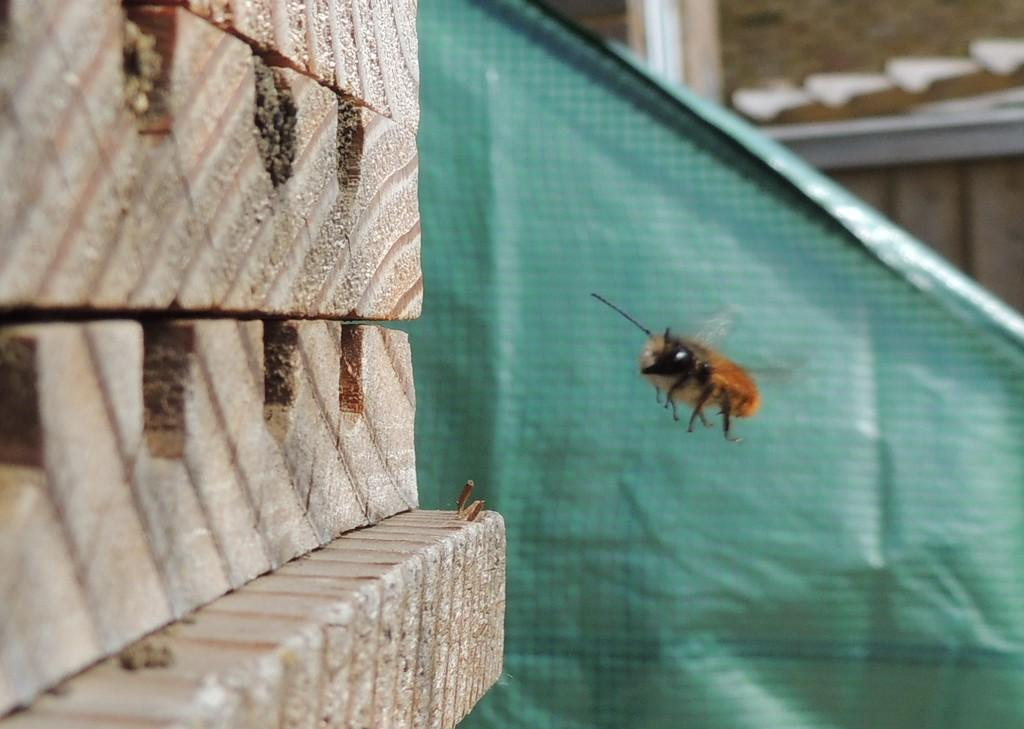What is flying in the image? There is an insect flying in the image. What can be seen on the left side of the image? There are bricks on the left side of the image. What is visible in the background of the image? There is a sheet and a house in the background of the image. What type of fan is being used to cool down the company in the image? There is no fan or company present in the image; it features an insect flying near bricks, a sheet, and a house in the background. 